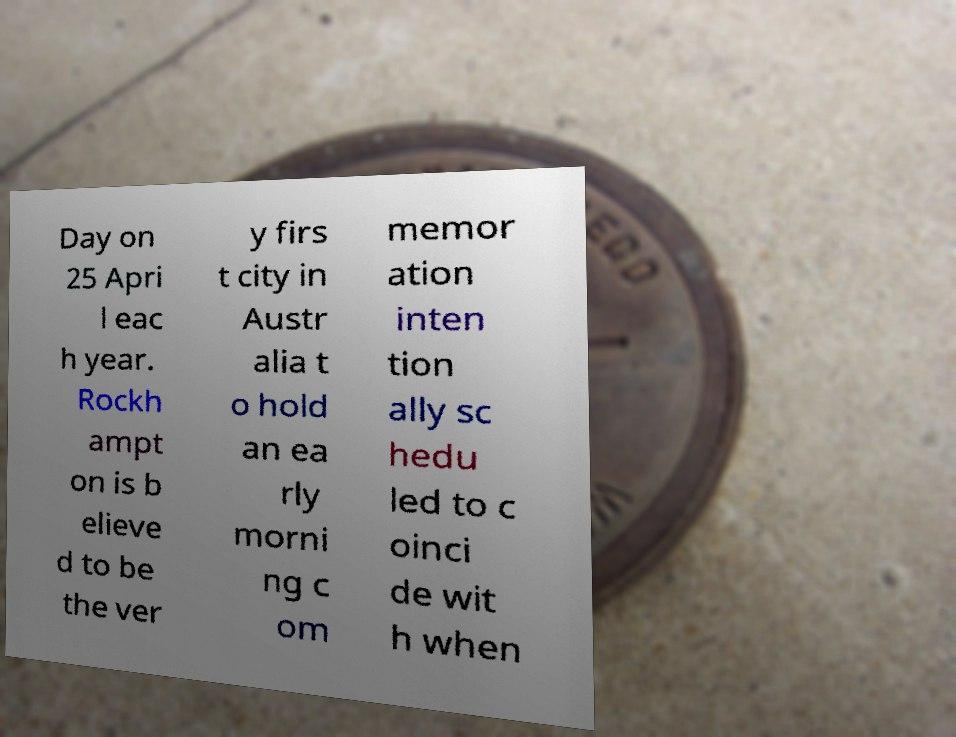Can you accurately transcribe the text from the provided image for me? Day on 25 Apri l eac h year. Rockh ampt on is b elieve d to be the ver y firs t city in Austr alia t o hold an ea rly morni ng c om memor ation inten tion ally sc hedu led to c oinci de wit h when 